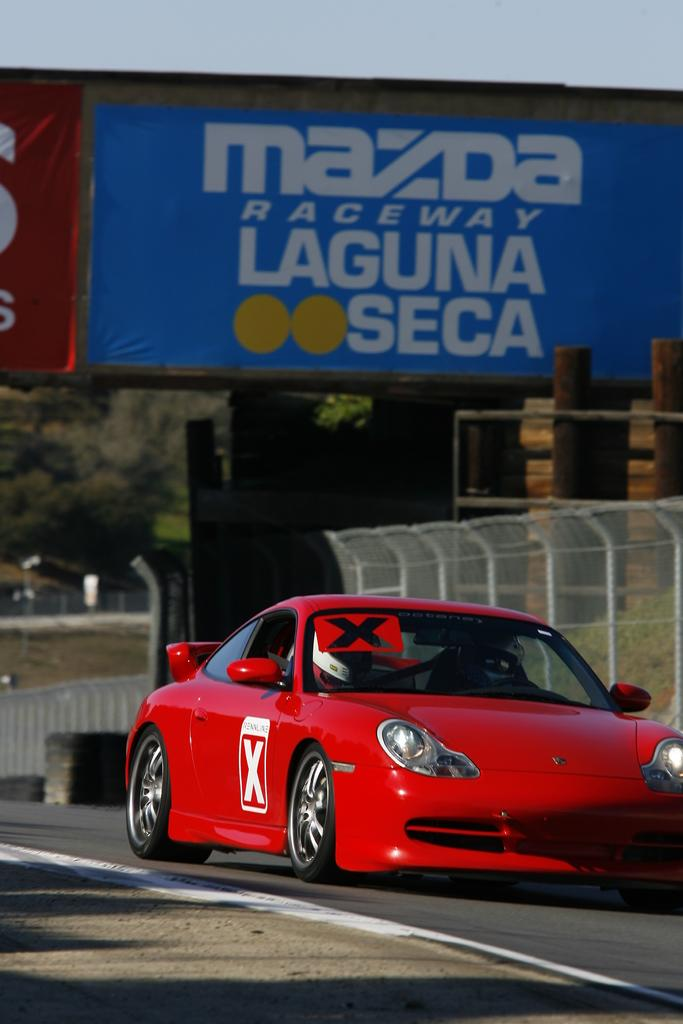What is the color of the car in the image? The car is red. Where is the car located in the image? The car is on the road. What can be seen behind the car? There is a fence, a hoarding, trees, and the sky visible behind the car. How many zebras are standing under the car in the image? There are no zebras present in the image, and they are not standing under the car. 